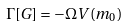<formula> <loc_0><loc_0><loc_500><loc_500>\Gamma [ G ] = - \Omega V ( m _ { 0 } )</formula> 